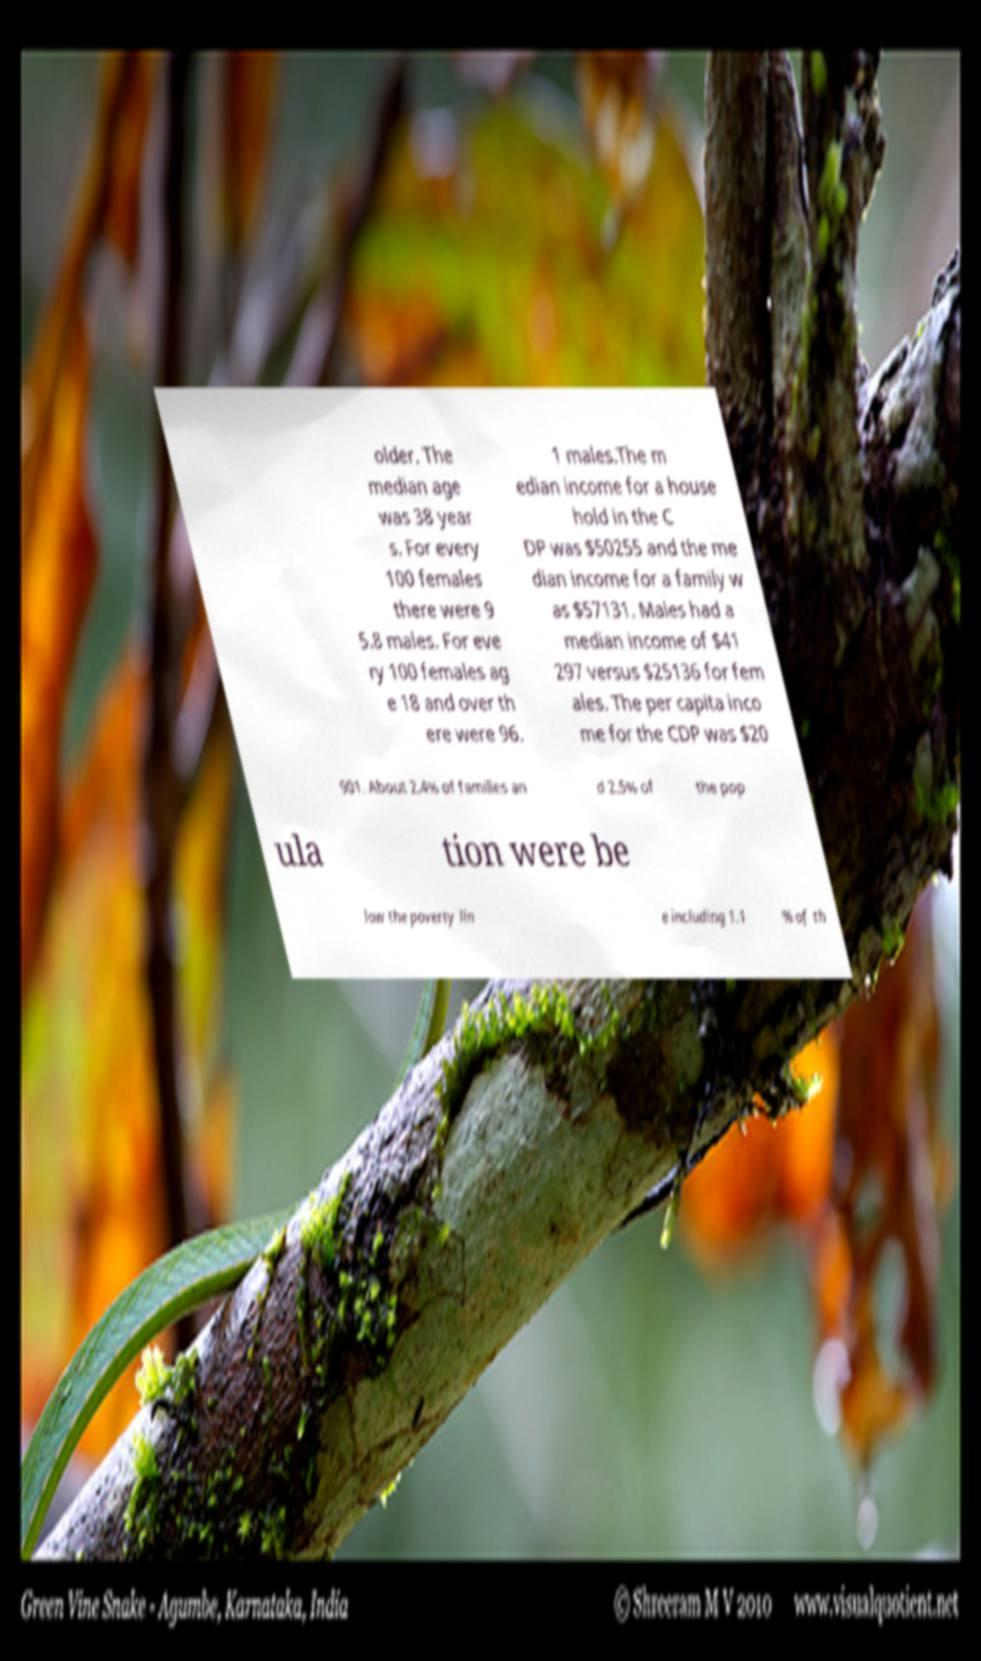Can you read and provide the text displayed in the image?This photo seems to have some interesting text. Can you extract and type it out for me? older. The median age was 38 year s. For every 100 females there were 9 5.8 males. For eve ry 100 females ag e 18 and over th ere were 96. 1 males.The m edian income for a house hold in the C DP was $50255 and the me dian income for a family w as $57131. Males had a median income of $41 297 versus $25136 for fem ales. The per capita inco me for the CDP was $20 901. About 2.4% of families an d 2.5% of the pop ula tion were be low the poverty lin e including 1.1 % of th 